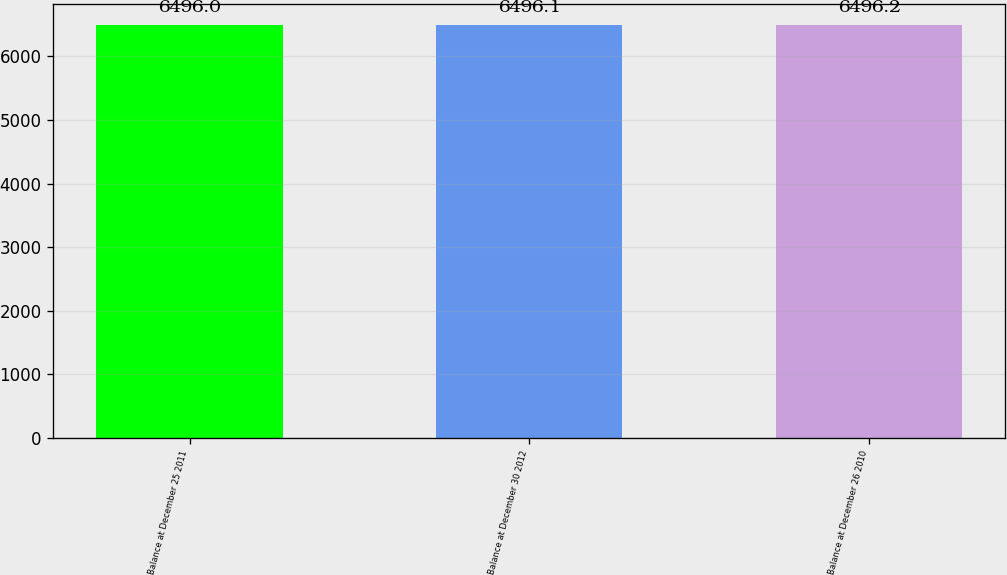Convert chart to OTSL. <chart><loc_0><loc_0><loc_500><loc_500><bar_chart><fcel>Balance at December 25 2011<fcel>Balance at December 30 2012<fcel>Balance at December 26 2010<nl><fcel>6496<fcel>6496.1<fcel>6496.2<nl></chart> 